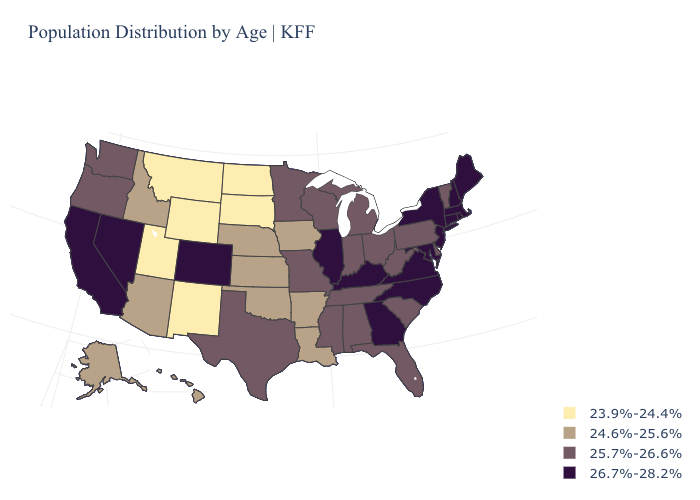What is the highest value in states that border Wyoming?
Answer briefly. 26.7%-28.2%. How many symbols are there in the legend?
Be succinct. 4. Does the map have missing data?
Answer briefly. No. Which states have the lowest value in the Northeast?
Write a very short answer. Pennsylvania, Vermont. Name the states that have a value in the range 23.9%-24.4%?
Keep it brief. Montana, New Mexico, North Dakota, South Dakota, Utah, Wyoming. Among the states that border Maryland , does Pennsylvania have the lowest value?
Write a very short answer. Yes. Does Hawaii have a lower value than Kentucky?
Concise answer only. Yes. Which states have the lowest value in the West?
Keep it brief. Montana, New Mexico, Utah, Wyoming. What is the lowest value in the West?
Give a very brief answer. 23.9%-24.4%. Among the states that border Wyoming , which have the highest value?
Short answer required. Colorado. Name the states that have a value in the range 26.7%-28.2%?
Write a very short answer. California, Colorado, Connecticut, Georgia, Illinois, Kentucky, Maine, Maryland, Massachusetts, Nevada, New Hampshire, New Jersey, New York, North Carolina, Rhode Island, Virginia. What is the lowest value in the USA?
Give a very brief answer. 23.9%-24.4%. Name the states that have a value in the range 24.6%-25.6%?
Keep it brief. Alaska, Arizona, Arkansas, Hawaii, Idaho, Iowa, Kansas, Louisiana, Nebraska, Oklahoma. Among the states that border North Dakota , which have the lowest value?
Concise answer only. Montana, South Dakota. Among the states that border Missouri , does Illinois have the highest value?
Be succinct. Yes. 